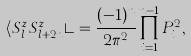<formula> <loc_0><loc_0><loc_500><loc_500>\langle S _ { l } ^ { z } S _ { l + 2 n } ^ { z } \rangle = \frac { ( - 1 ) ^ { n } } { 2 \pi ^ { 2 } } \prod _ { i = 1 } ^ { n - 1 } P _ { i } ^ { 2 } ,</formula> 